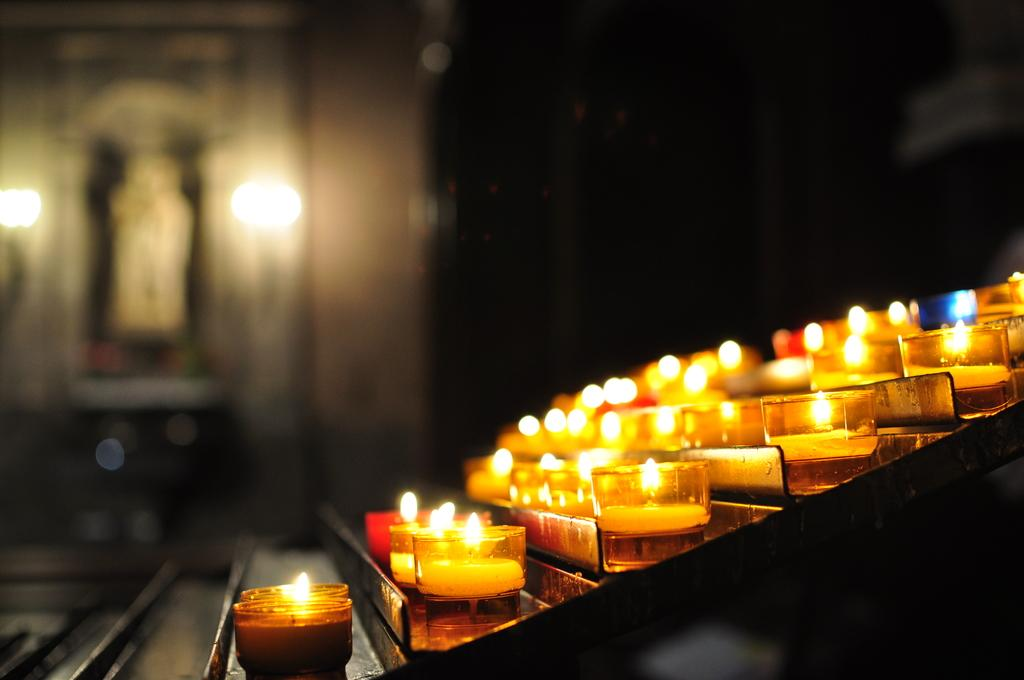What type of lighting is present in the image? There are candle lights in the image. Where are the candle lights placed? The candle lights are placed on a stand. What else can be seen in the background of the image? There are lights, a photo frame, and a wall in the background of the image. What type of needle is used to sew the fabric on the desk in the image? There is no desk or fabric present in the image; it only features candle lights, a stand, and background elements. 